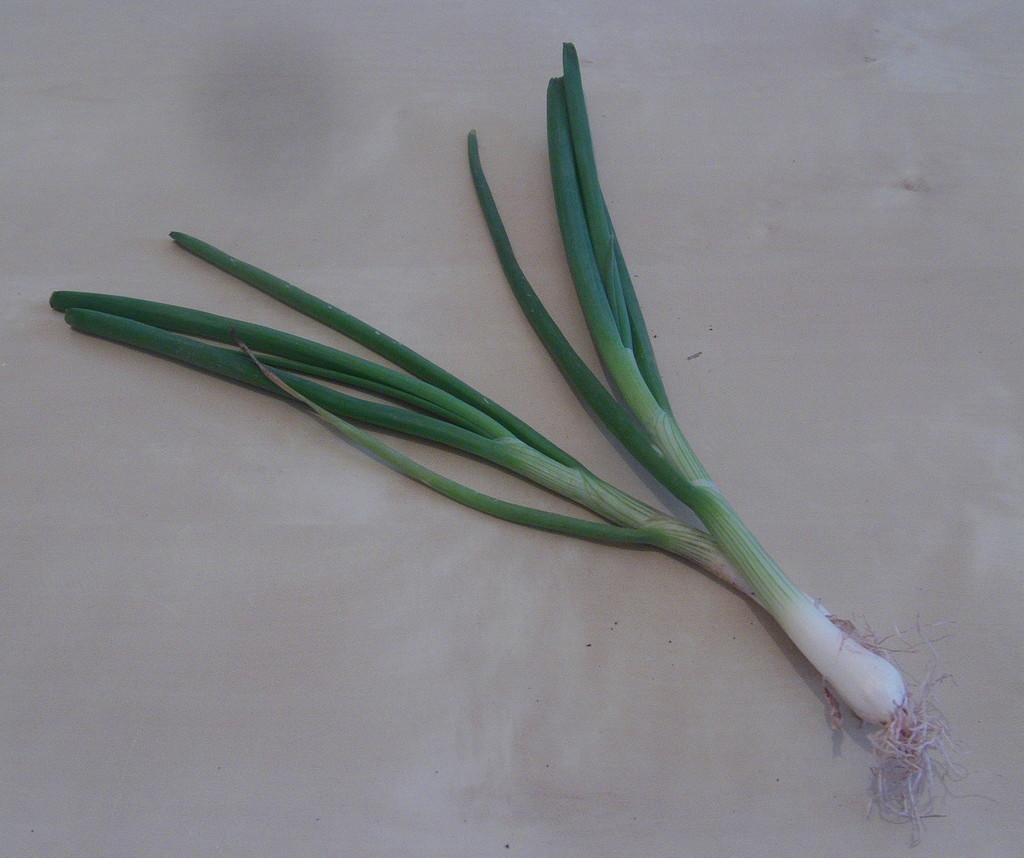Could you give a brief overview of what you see in this image? In this image we can see two green spring onions on the white surface looks like a floor. 